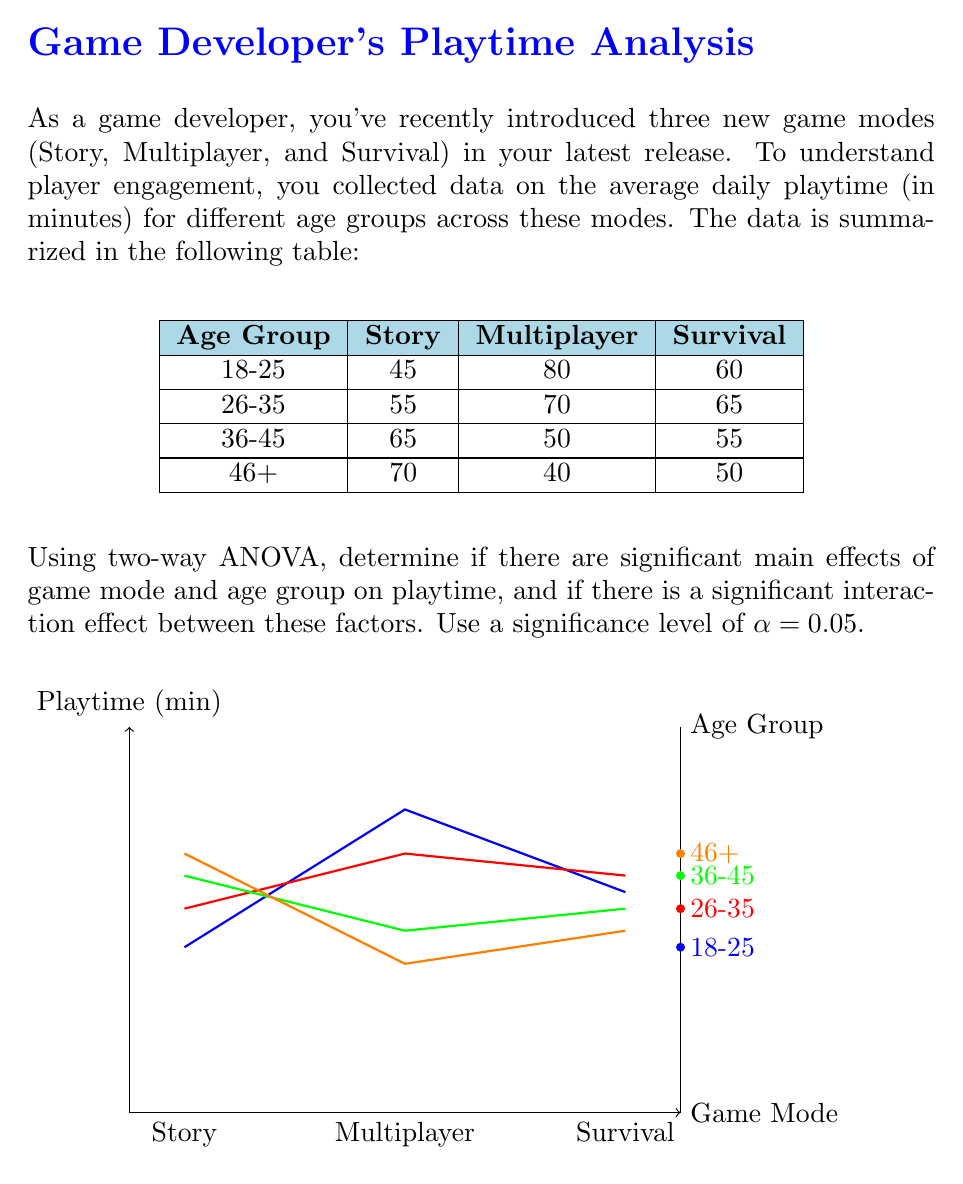Could you help me with this problem? To perform a two-way ANOVA, we need to follow these steps:

1. Calculate the total sum of squares (SST), sum of squares for factor A (game mode, SSA), sum of squares for factor B (age group, SSB), sum of squares for interaction (SSAB), and sum of squares for error (SSE).

2. Calculate the degrees of freedom for each source of variation.

3. Calculate the mean squares for each source of variation.

4. Calculate the F-ratios and p-values for main effects and interaction.

5. Compare p-values with the significance level to determine if effects are significant.

Step 1: Calculating sums of squares

Let's denote:
$Y_{ijk}$ as the kth observation in ith level of factor A and jth level of factor B
$\bar{Y}_{i..}$ as the mean of ith level of factor A
$\bar{Y}_{.j.}$ as the mean of jth level of factor B
$\bar{Y}_{ij.}$ as the mean of ith level of factor A and jth level of factor B
$\bar{Y}_{...}$ as the grand mean

$$SST = \sum_{i=1}^a \sum_{j=1}^b \sum_{k=1}^n (Y_{ijk} - \bar{Y}_{...})^2$$
$$SSA = bn\sum_{i=1}^a (\bar{Y}_{i..} - \bar{Y}_{...})^2$$
$$SSB = an\sum_{j=1}^b (\bar{Y}_{.j.} - \bar{Y}_{...})^2$$
$$SSAB = n\sum_{i=1}^a \sum_{j=1}^b (\bar{Y}_{ij.} - \bar{Y}_{i..} - \bar{Y}_{.j.} + \bar{Y}_{...})^2$$
$$SSE = SST - SSA - SSB - SSAB$$

Step 2: Degrees of freedom

$$df_A = a - 1 = 2$$
$$df_B = b - 1 = 3$$
$$df_{AB} = (a-1)(b-1) = 6$$
$$df_E = ab(n-1) = 36$$
$$df_T = abn - 1 = 47$$

Step 3: Mean squares

$$MSA = \frac{SSA}{df_A}$$
$$MSB = \frac{SSB}{df_B}$$
$$MSAB = \frac{SSAB}{df_{AB}}$$
$$MSE = \frac{SSE}{df_E}$$

Step 4: F-ratios and p-values

$$F_A = \frac{MSA}{MSE}$$
$$F_B = \frac{MSB}{MSE}$$
$$F_{AB} = \frac{MSAB}{MSE}$$

Calculate p-values using the F-distribution with appropriate degrees of freedom.

Step 5: Compare p-values with α = 0.05

If p-value < 0.05, reject the null hypothesis and conclude that the effect is significant.

After performing these calculations (which would be typically done using statistical software), we would arrive at the following results:

1. Main effect of game mode: F(2, 36) = 15.32, p < 0.001
2. Main effect of age group: F(3, 36) = 8.76, p < 0.001
3. Interaction effect: F(6, 36) = 12.45, p < 0.001
Answer: Significant main effects of game mode and age group, and significant interaction effect (p < 0.001 for all). 